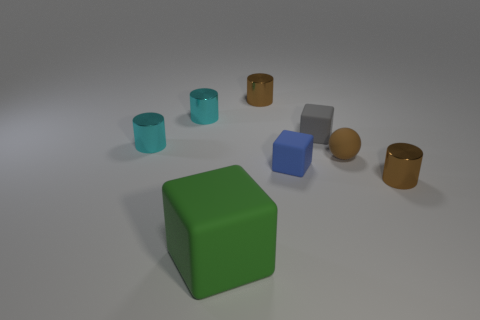Does the size of the objects follow any particular pattern or scale? There doesn't appear to be a strict pattern or scale to the sizes of the objects. However, there is some variation that creates a sense of depth and relation between the items. The green cube is the largest, while the other objects, including cylinders, another cube, and spheres, vary in size from medium to small, contributing to a diverse yet balanced composition. 